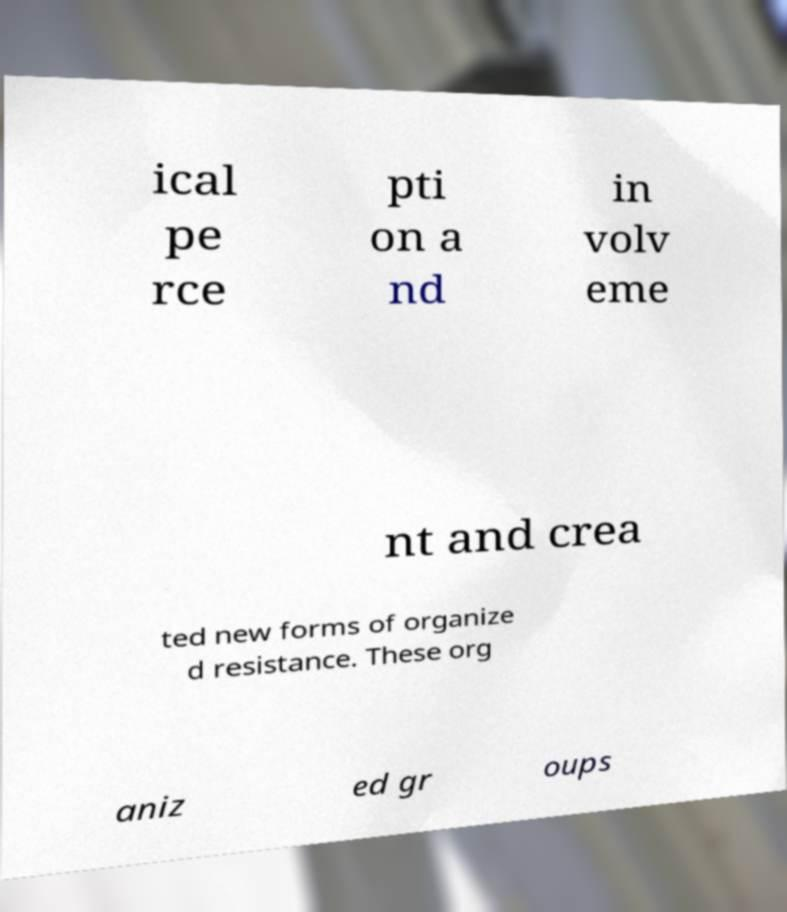There's text embedded in this image that I need extracted. Can you transcribe it verbatim? ical pe rce pti on a nd in volv eme nt and crea ted new forms of organize d resistance. These org aniz ed gr oups 